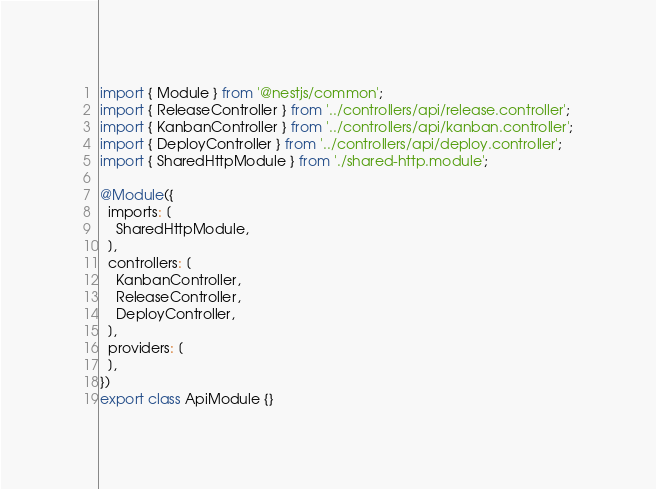<code> <loc_0><loc_0><loc_500><loc_500><_TypeScript_>import { Module } from '@nestjs/common';
import { ReleaseController } from '../controllers/api/release.controller';
import { KanbanController } from '../controllers/api/kanban.controller';
import { DeployController } from '../controllers/api/deploy.controller';
import { SharedHttpModule } from './shared-http.module';

@Module({
  imports: [
    SharedHttpModule,
  ],
  controllers: [
    KanbanController,
    ReleaseController,
    DeployController,
  ],
  providers: [
  ],
})
export class ApiModule {}
</code> 